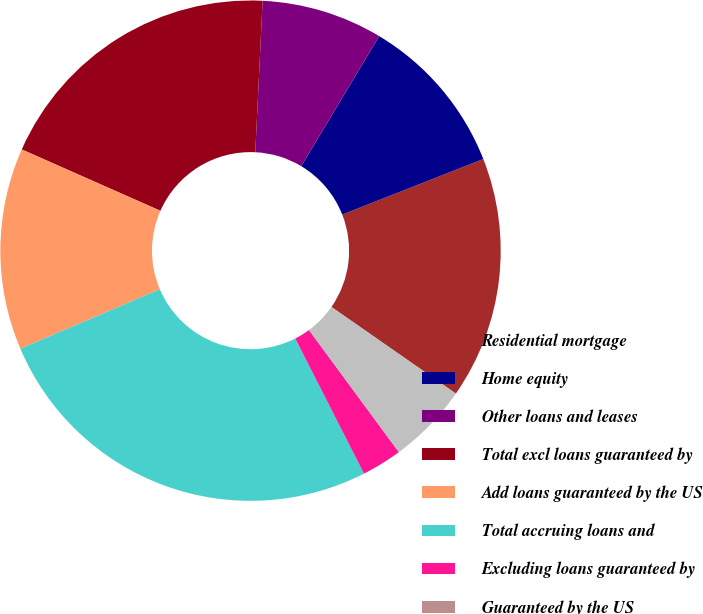Convert chart. <chart><loc_0><loc_0><loc_500><loc_500><pie_chart><fcel>Residential mortgage<fcel>Home equity<fcel>Other loans and leases<fcel>Total excl loans guaranteed by<fcel>Add loans guaranteed by the US<fcel>Total accruing loans and<fcel>Excluding loans guaranteed by<fcel>Guaranteed by the US<fcel>Including loans guaranteed by<nl><fcel>15.65%<fcel>10.43%<fcel>7.83%<fcel>19.14%<fcel>13.04%<fcel>26.08%<fcel>2.61%<fcel>0.0%<fcel>5.22%<nl></chart> 